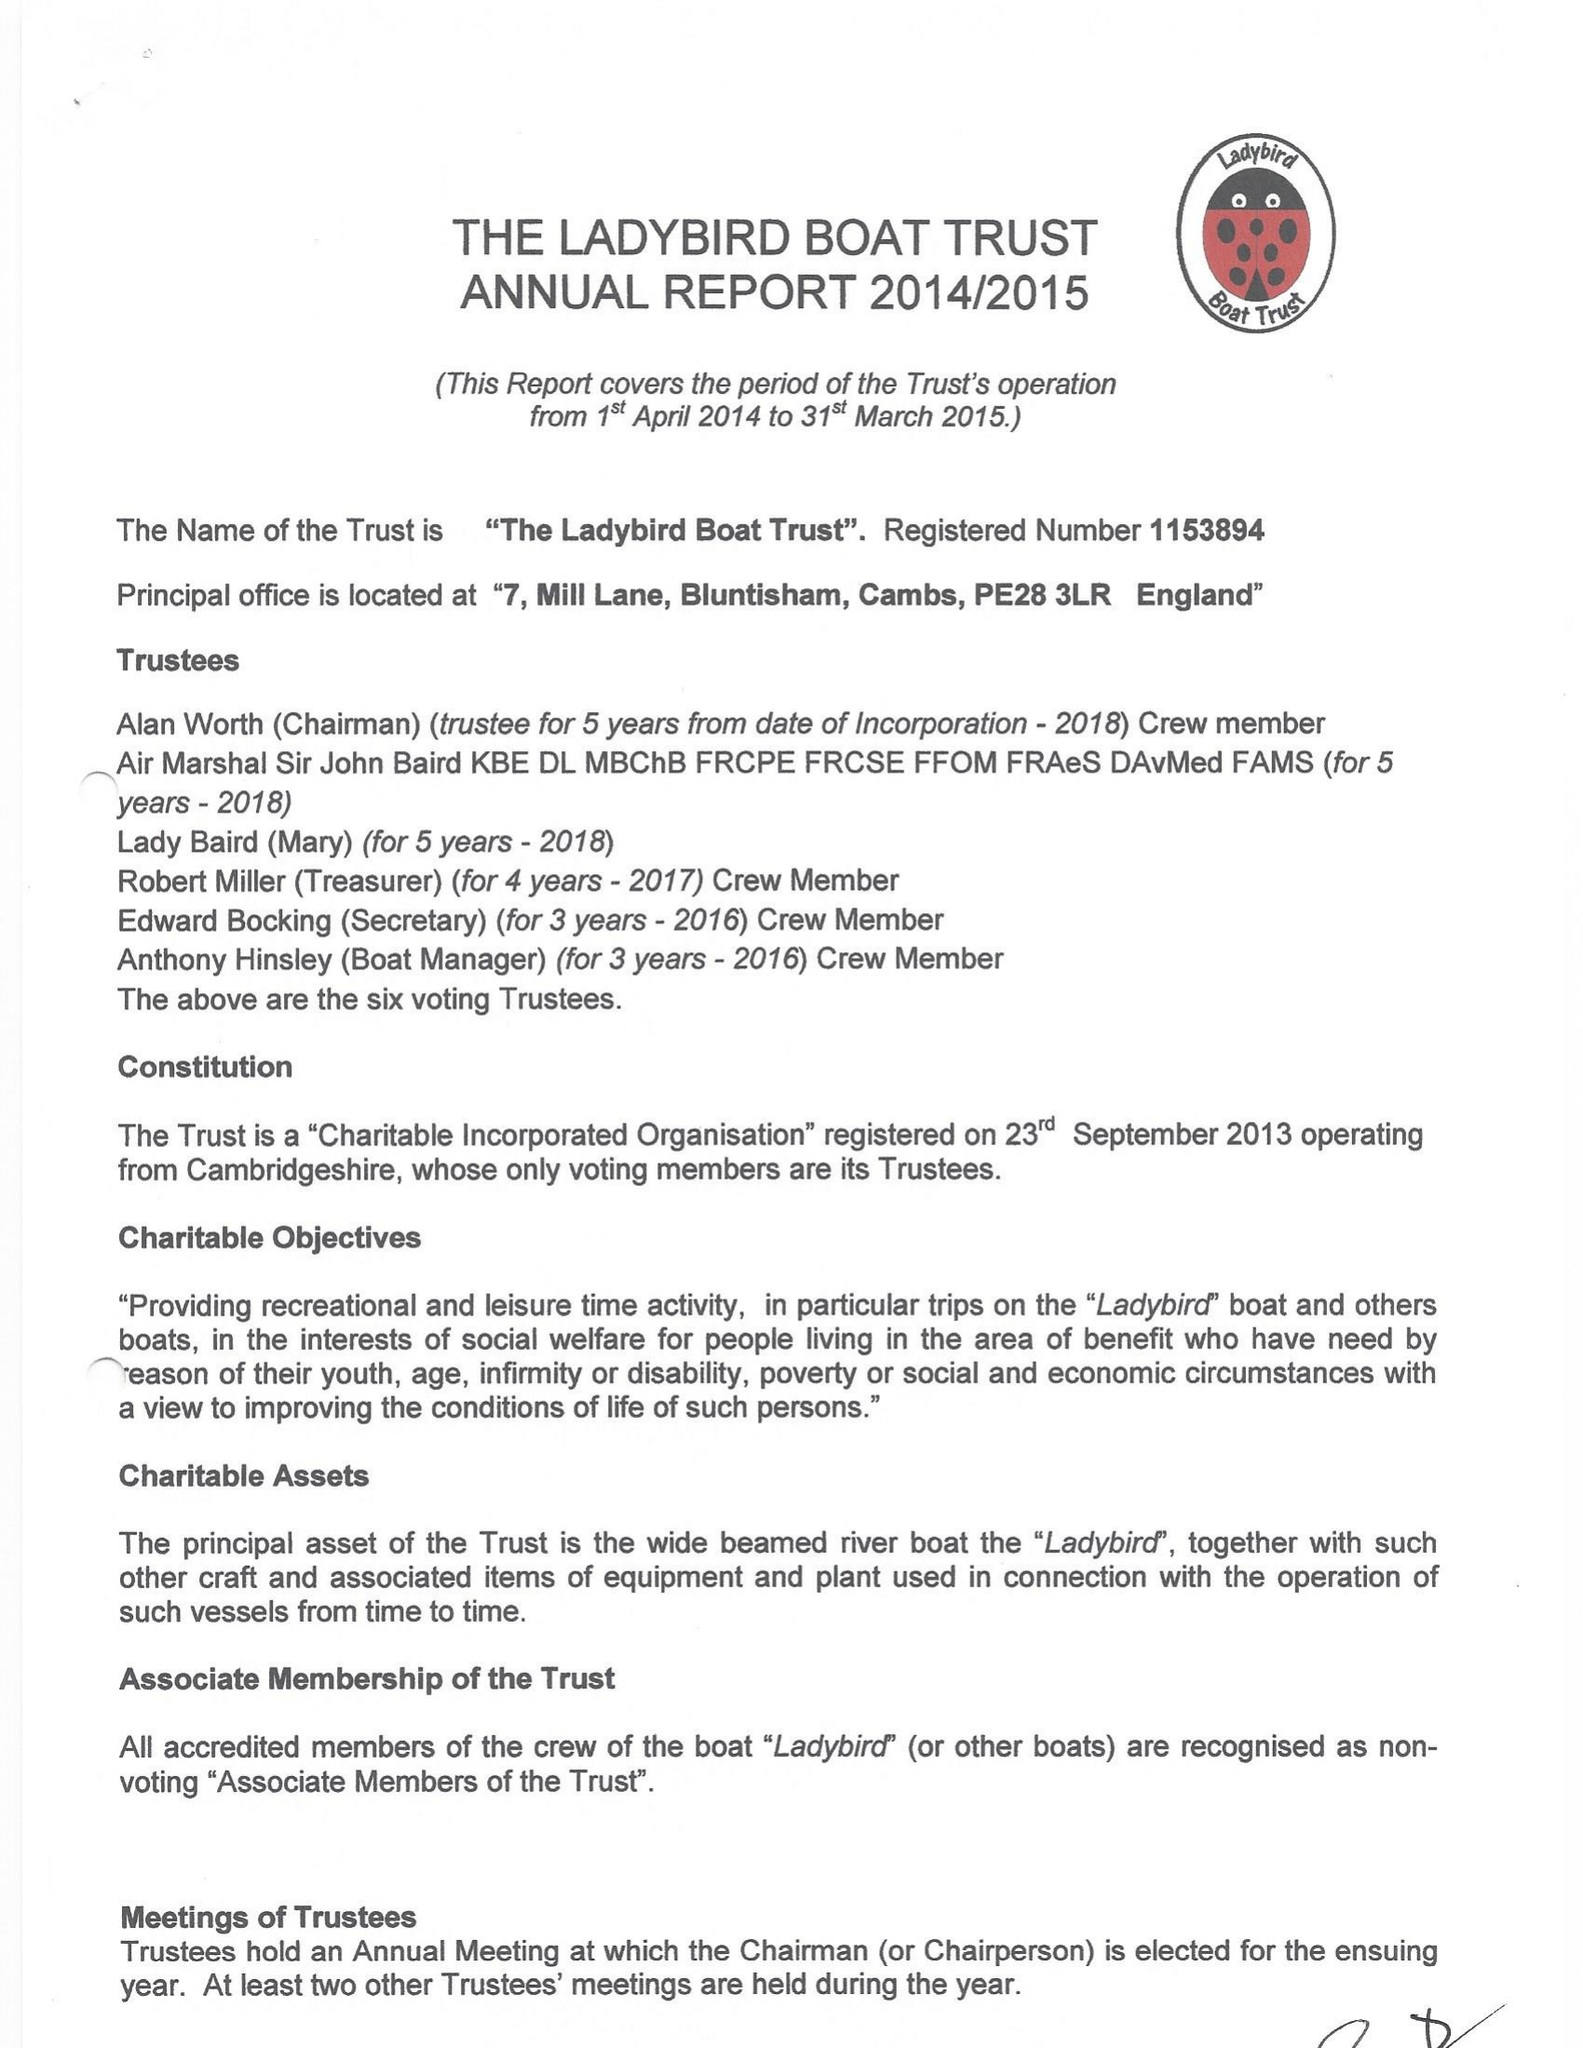What is the value for the address__post_town?
Answer the question using a single word or phrase. HUNTINGDON 